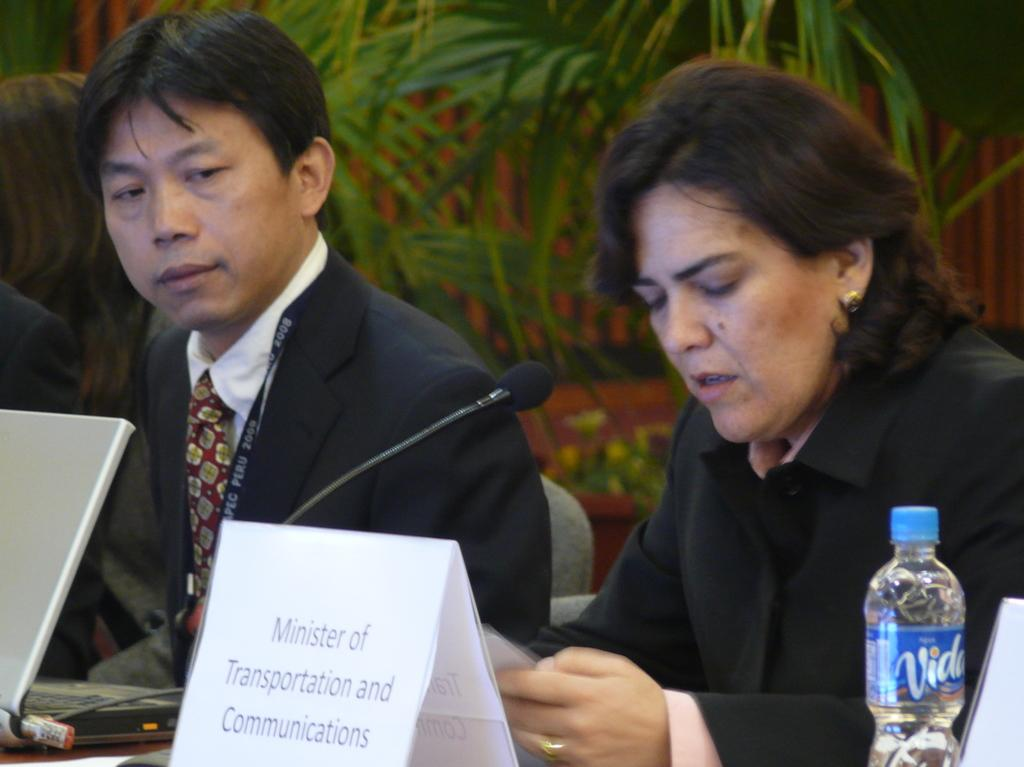How many people are sitting at the desk in the image? There are two persons sitting at the desk in the image. What electronic device is on the desk? There is a laptop on the desk. What is used for recording audio on the desk? There is a microphone (mic) on the desk. What is the purpose of the board on the desk? The purpose of the board on the desk is not specified, but it could be used for writing or displaying information. What is used for hydration on the desk? There is a water bottle on the desk. What can be seen in the background of the image? There is a wall in the background of the image, and there are plants in the background as well. What type of yoke can be seen in the image? There is no yoke present in the image. 